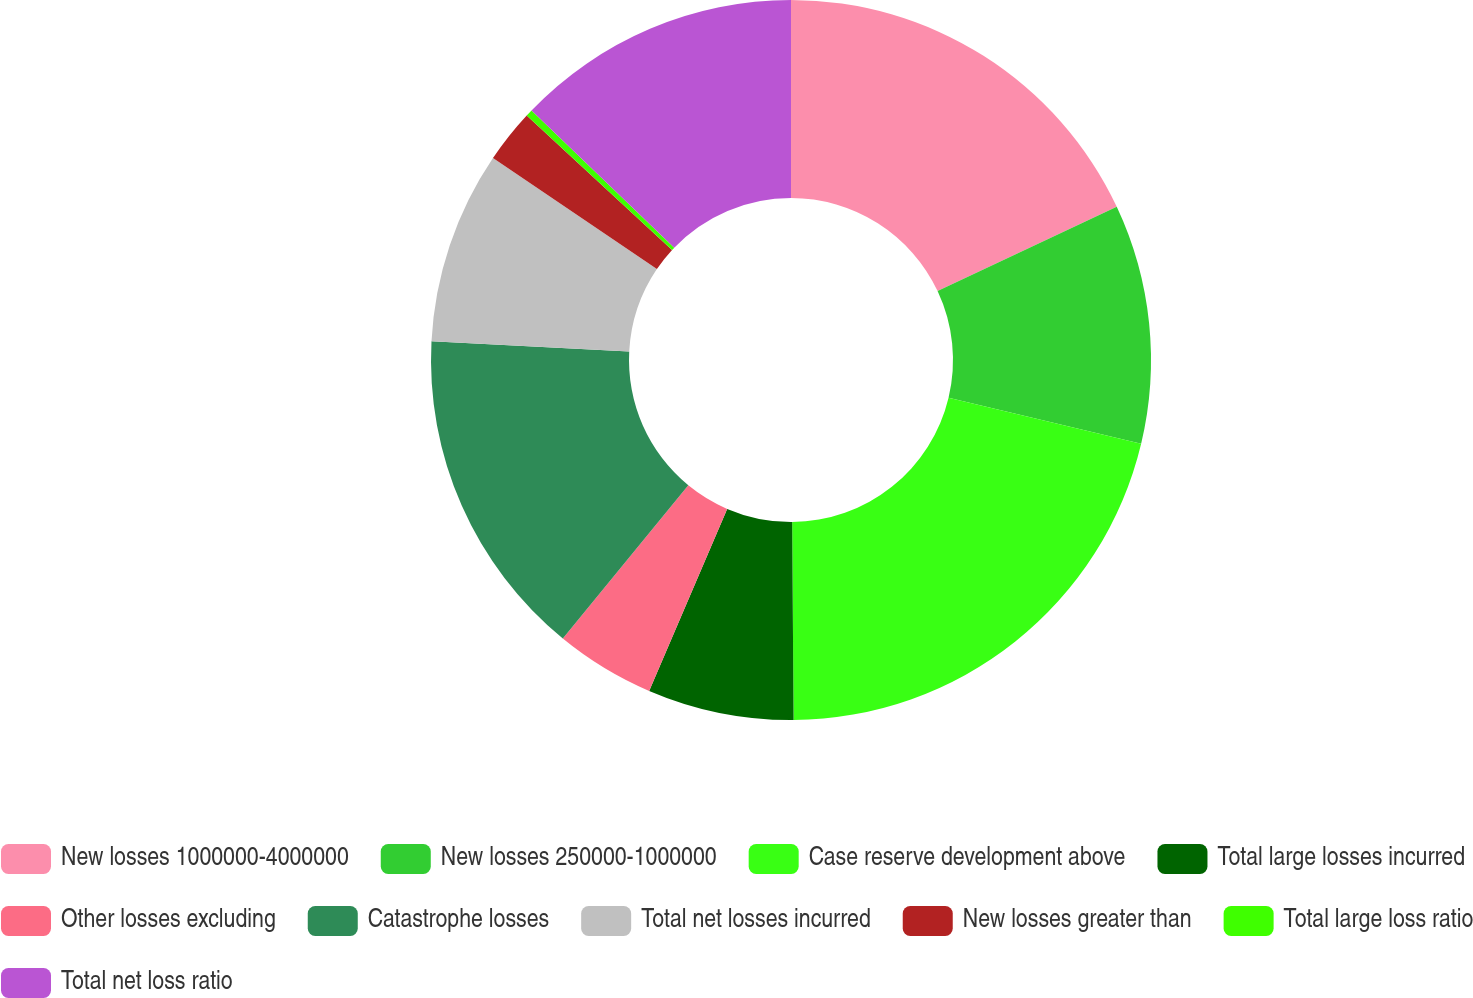<chart> <loc_0><loc_0><loc_500><loc_500><pie_chart><fcel>New losses 1000000-4000000<fcel>New losses 250000-1000000<fcel>Case reserve development above<fcel>Total large losses incurred<fcel>Other losses excluding<fcel>Catastrophe losses<fcel>Total net losses incurred<fcel>New losses greater than<fcel>Total large loss ratio<fcel>Total net loss ratio<nl><fcel>18.0%<fcel>10.73%<fcel>21.15%<fcel>6.56%<fcel>4.48%<fcel>14.9%<fcel>8.65%<fcel>2.4%<fcel>0.31%<fcel>12.81%<nl></chart> 